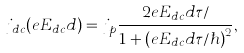<formula> <loc_0><loc_0><loc_500><loc_500>j _ { d c } ( e E _ { d c } d ) = j _ { p } \frac { 2 e E _ { d c } d \tau / } { 1 + ( e E _ { d c } d \tau / \hbar { ) } ^ { 2 } } ,</formula> 